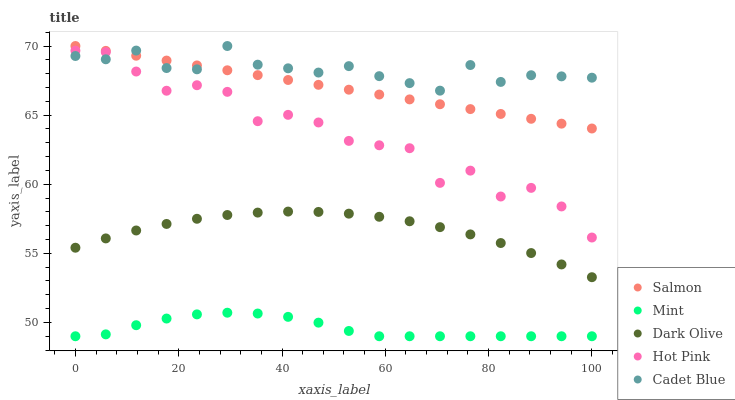Does Mint have the minimum area under the curve?
Answer yes or no. Yes. Does Cadet Blue have the maximum area under the curve?
Answer yes or no. Yes. Does Dark Olive have the minimum area under the curve?
Answer yes or no. No. Does Dark Olive have the maximum area under the curve?
Answer yes or no. No. Is Salmon the smoothest?
Answer yes or no. Yes. Is Hot Pink the roughest?
Answer yes or no. Yes. Is Mint the smoothest?
Answer yes or no. No. Is Mint the roughest?
Answer yes or no. No. Does Mint have the lowest value?
Answer yes or no. Yes. Does Dark Olive have the lowest value?
Answer yes or no. No. Does Salmon have the highest value?
Answer yes or no. Yes. Does Dark Olive have the highest value?
Answer yes or no. No. Is Hot Pink less than Salmon?
Answer yes or no. Yes. Is Hot Pink greater than Dark Olive?
Answer yes or no. Yes. Does Cadet Blue intersect Hot Pink?
Answer yes or no. Yes. Is Cadet Blue less than Hot Pink?
Answer yes or no. No. Is Cadet Blue greater than Hot Pink?
Answer yes or no. No. Does Hot Pink intersect Salmon?
Answer yes or no. No. 